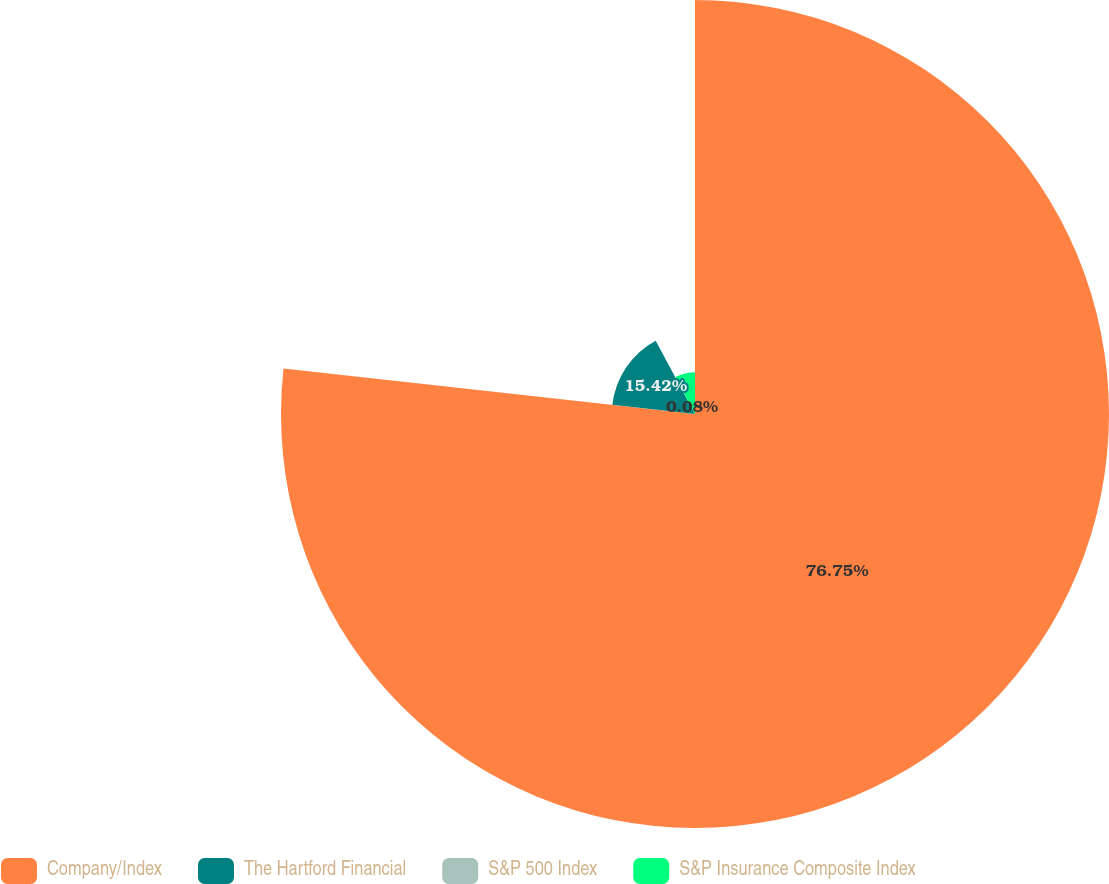Convert chart. <chart><loc_0><loc_0><loc_500><loc_500><pie_chart><fcel>Company/Index<fcel>The Hartford Financial<fcel>S&P 500 Index<fcel>S&P Insurance Composite Index<nl><fcel>76.76%<fcel>15.42%<fcel>0.08%<fcel>7.75%<nl></chart> 